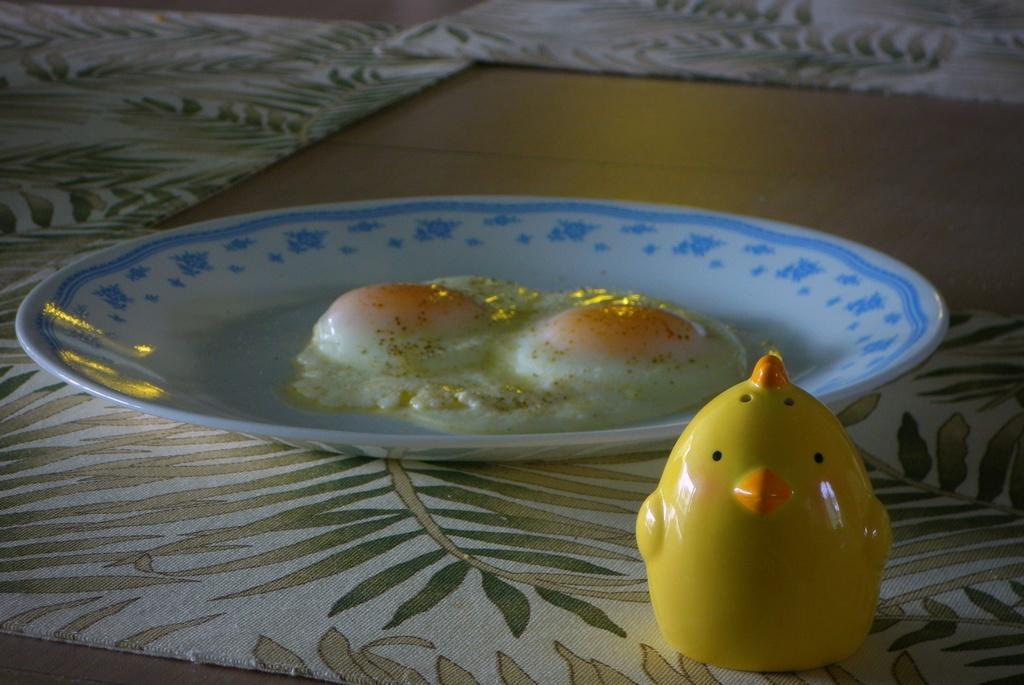What is on the plate that is visible in the image? There is food on a plate in the image. What color is the plate? The plate is white in color. Where is the plate located in the image? The plate is on a table. What other object can be seen in front of the plate? There is a yellow toy in front of the plate. Is there a peaceful island in the background of the image? There is no island present in the image, and therefore no information about its peacefulness can be determined. 